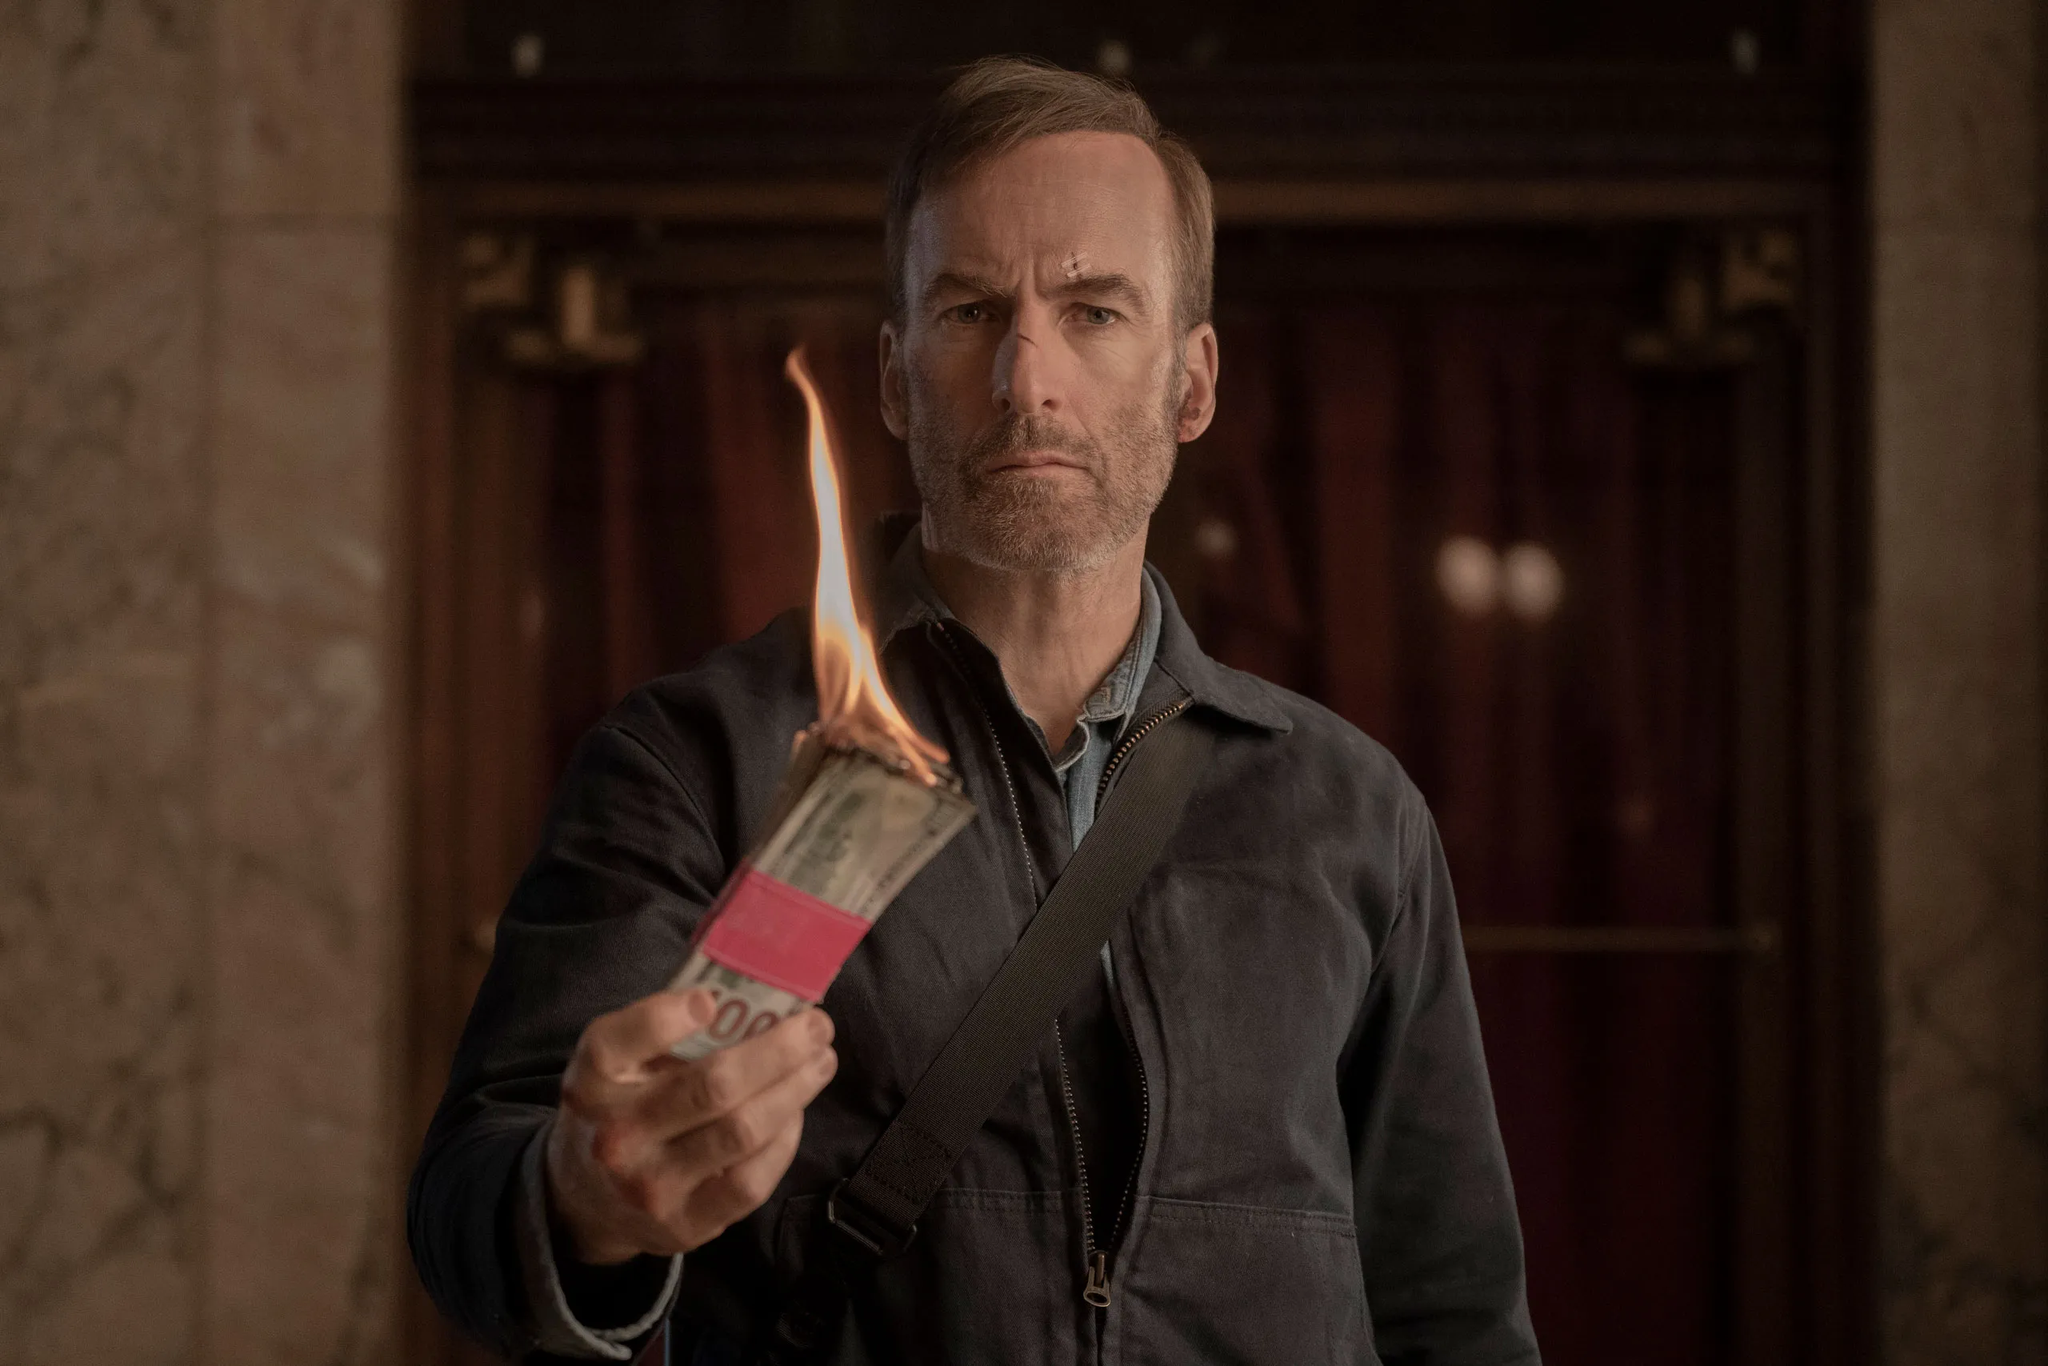What message do you think the burning money could be symbolizing in this scene? The burning stack of money in the image likely symbolizes a rejection of material wealth or a moment of desperation. It might represent the character's disdain for money, a drastic move to make a statement, or perhaps even an ultimate sacrifice for a higher cause. The symbolism can be multifaceted, adding depth to the character's actions and the overall narrative. Do you think the character looks remorseful for burning the money? The character does not appear remorseful. His expression is stern and determined, suggesting that he is fully aware of his actions and the consequences but feels that this is a necessary step. This adds a layer of complexity to the scene, making the audience question his motivations and what led him to this drastic measure. Create an imaginative backstory for this scene. In a city torn by corruption and greed, John, a former wealthy businessman, has become disillusioned with the world he once thrived in. After a series of personal tragedies and financial collapses instigated by his former partners, he decides to take a stand. Realizing that the society around him is driven by a relentless pursuit of wealth, John sets out on a radical mission to expose the true cost of their greed. Finding himself inside the grandiose lobby of the bank that once held all his savings, he sets a bundle of his remaining money ablaze, symbolizing his rejection of the very thing that cost him everything. With every bill that burns, John feels a moment of liberation, determined to bring a new kind of justice to the world he lives in. 